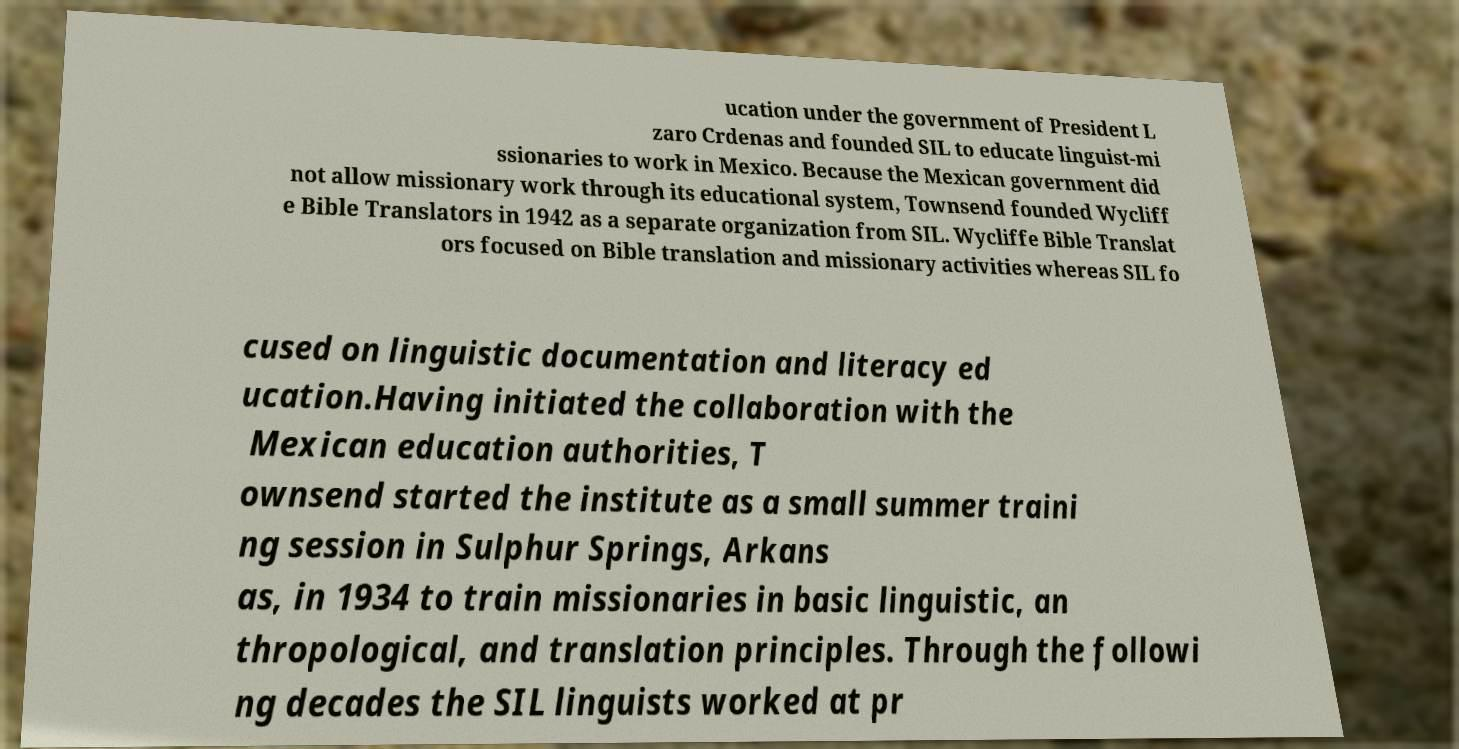Please read and relay the text visible in this image. What does it say? ucation under the government of President L zaro Crdenas and founded SIL to educate linguist-mi ssionaries to work in Mexico. Because the Mexican government did not allow missionary work through its educational system, Townsend founded Wycliff e Bible Translators in 1942 as a separate organization from SIL. Wycliffe Bible Translat ors focused on Bible translation and missionary activities whereas SIL fo cused on linguistic documentation and literacy ed ucation.Having initiated the collaboration with the Mexican education authorities, T ownsend started the institute as a small summer traini ng session in Sulphur Springs, Arkans as, in 1934 to train missionaries in basic linguistic, an thropological, and translation principles. Through the followi ng decades the SIL linguists worked at pr 